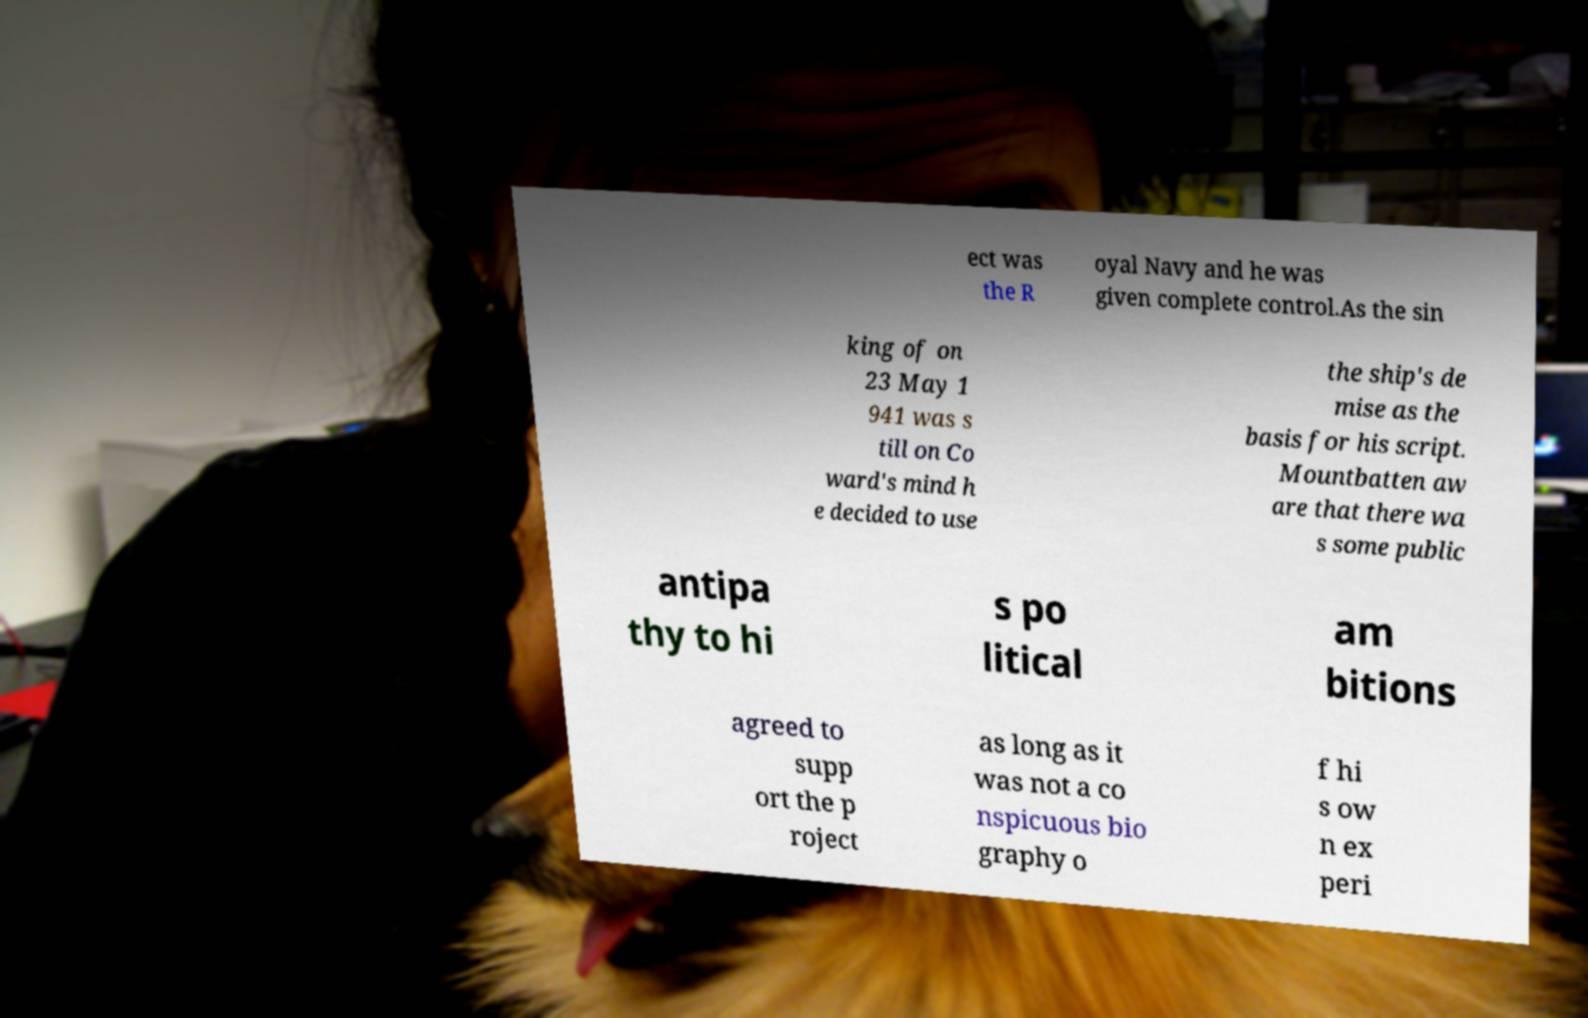There's text embedded in this image that I need extracted. Can you transcribe it verbatim? ect was the R oyal Navy and he was given complete control.As the sin king of on 23 May 1 941 was s till on Co ward's mind h e decided to use the ship's de mise as the basis for his script. Mountbatten aw are that there wa s some public antipa thy to hi s po litical am bitions agreed to supp ort the p roject as long as it was not a co nspicuous bio graphy o f hi s ow n ex peri 